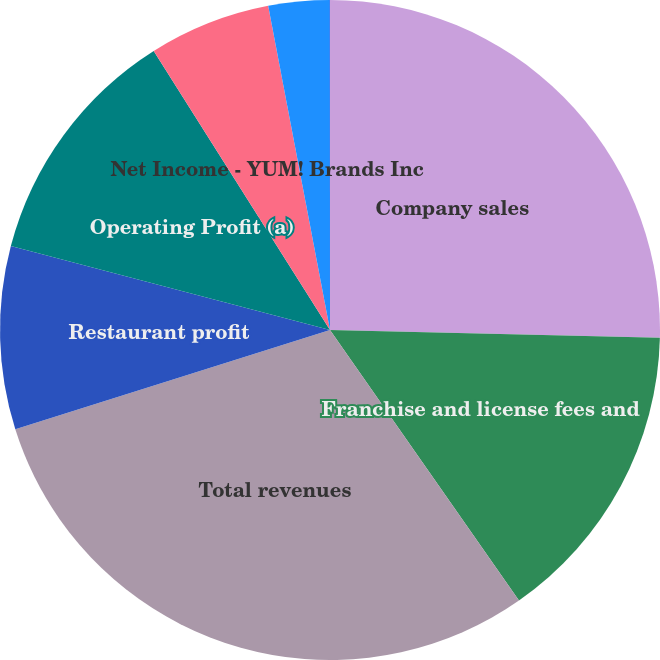Convert chart to OTSL. <chart><loc_0><loc_0><loc_500><loc_500><pie_chart><fcel>Company sales<fcel>Franchise and license fees and<fcel>Total revenues<fcel>Restaurant profit<fcel>Operating Profit (a)<fcel>Net Income - YUM! Brands Inc<fcel>Basic earnings per common<fcel>Diluted earnings per common<nl><fcel>25.38%<fcel>14.92%<fcel>29.84%<fcel>8.96%<fcel>11.94%<fcel>5.97%<fcel>2.99%<fcel>0.01%<nl></chart> 